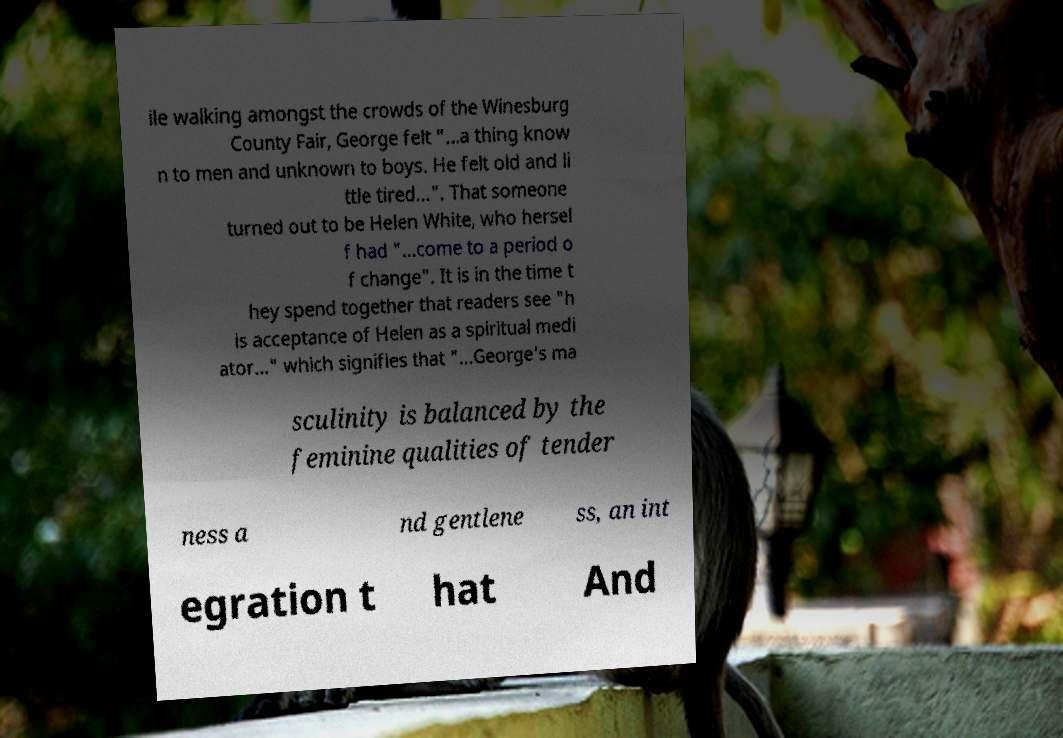There's text embedded in this image that I need extracted. Can you transcribe it verbatim? ile walking amongst the crowds of the Winesburg County Fair, George felt "...a thing know n to men and unknown to boys. He felt old and li ttle tired...". That someone turned out to be Helen White, who hersel f had "...come to a period o f change". It is in the time t hey spend together that readers see "h is acceptance of Helen as a spiritual medi ator..." which signifies that "...George's ma sculinity is balanced by the feminine qualities of tender ness a nd gentlene ss, an int egration t hat And 